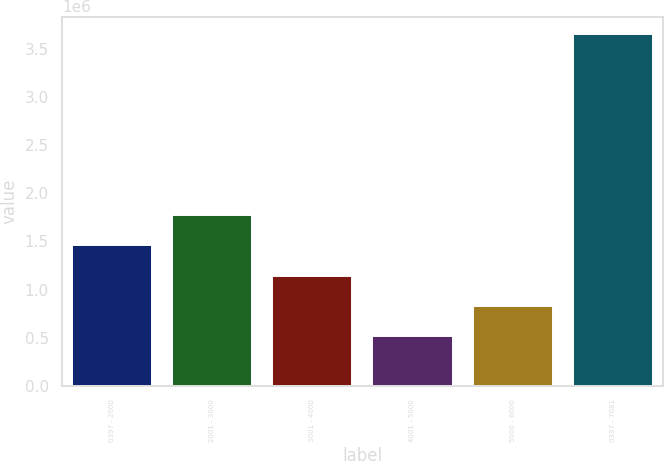<chart> <loc_0><loc_0><loc_500><loc_500><bar_chart><fcel>0397 - 2000<fcel>2001 - 3000<fcel>3001 - 4000<fcel>4001 - 5000<fcel>5000 - 6000<fcel>0397 - 7081<nl><fcel>1.4594e+06<fcel>1.7732e+06<fcel>1.1456e+06<fcel>518000<fcel>831800<fcel>3.656e+06<nl></chart> 